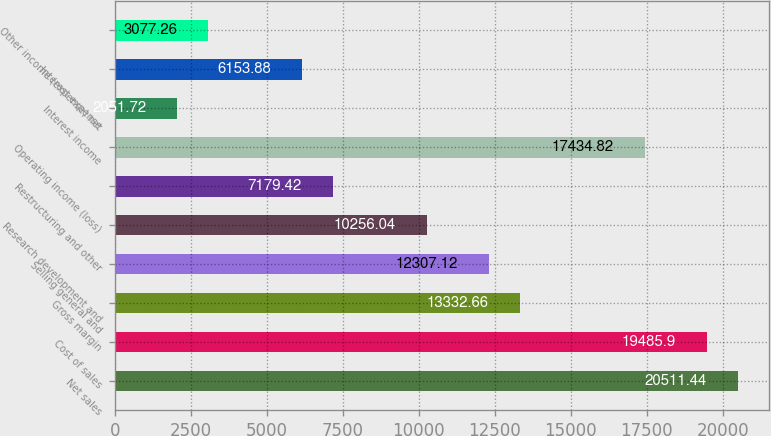Convert chart to OTSL. <chart><loc_0><loc_0><loc_500><loc_500><bar_chart><fcel>Net sales<fcel>Cost of sales<fcel>Gross margin<fcel>Selling general and<fcel>Research development and<fcel>Restructuring and other<fcel>Operating income (loss)<fcel>Interest income<fcel>Interest expense<fcel>Other income (expense) net<nl><fcel>20511.4<fcel>19485.9<fcel>13332.7<fcel>12307.1<fcel>10256<fcel>7179.42<fcel>17434.8<fcel>2051.72<fcel>6153.88<fcel>3077.26<nl></chart> 